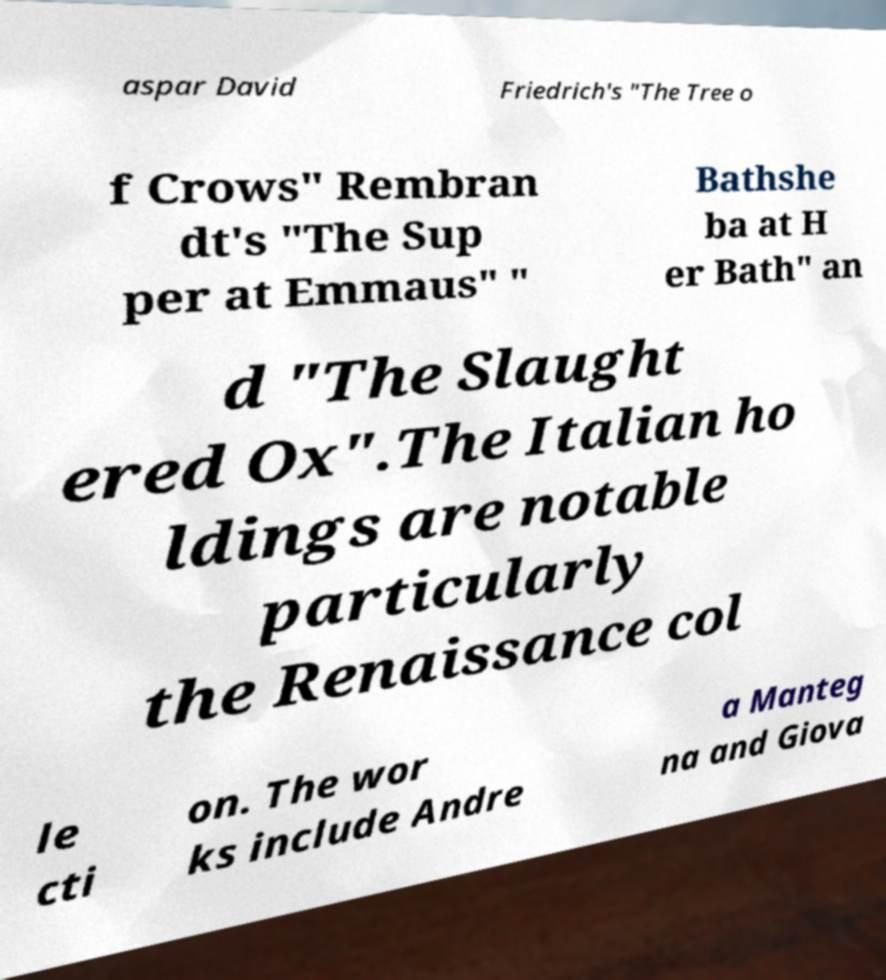There's text embedded in this image that I need extracted. Can you transcribe it verbatim? aspar David Friedrich's "The Tree o f Crows" Rembran dt's "The Sup per at Emmaus" " Bathshe ba at H er Bath" an d "The Slaught ered Ox".The Italian ho ldings are notable particularly the Renaissance col le cti on. The wor ks include Andre a Manteg na and Giova 